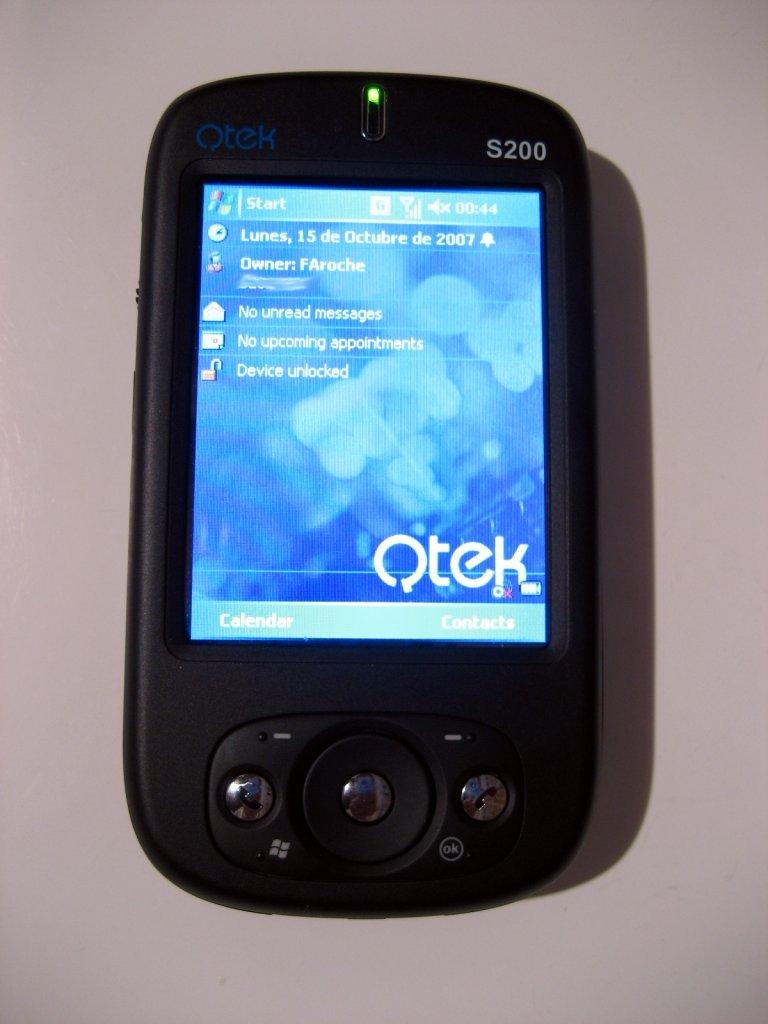What model number is this phone?
Ensure brevity in your answer.  S200. 